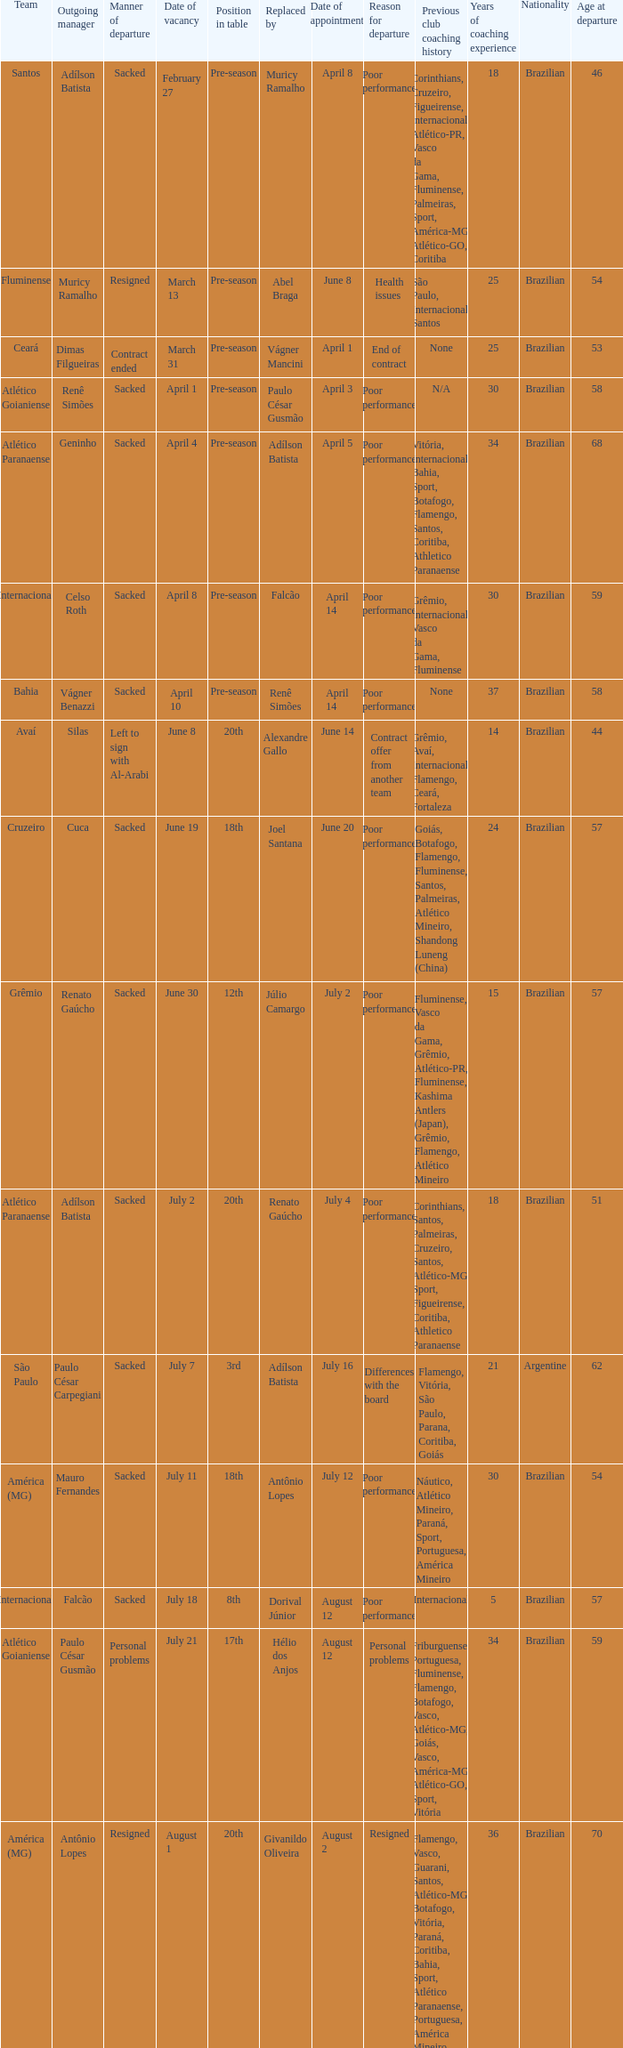What team hired Renato Gaúcho? Atlético Paranaense. 